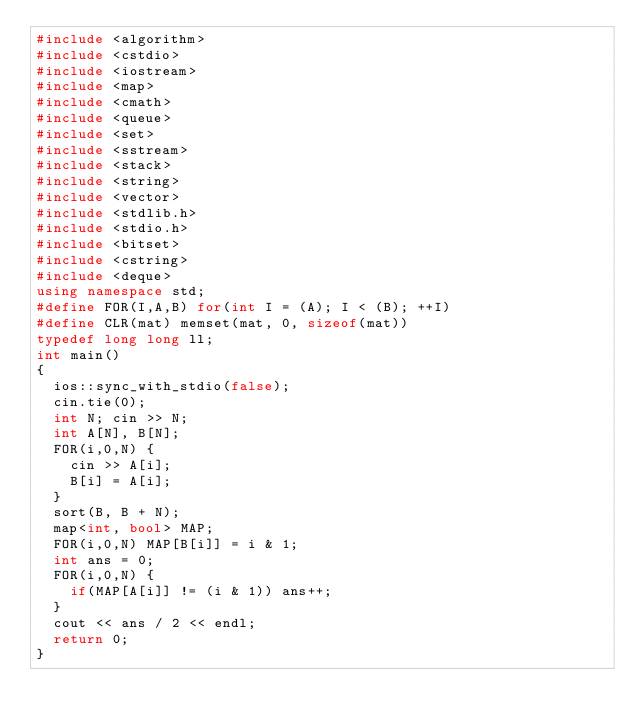<code> <loc_0><loc_0><loc_500><loc_500><_C++_>#include <algorithm>
#include <cstdio>
#include <iostream>
#include <map>
#include <cmath>
#include <queue>
#include <set>
#include <sstream>
#include <stack>
#include <string>
#include <vector>
#include <stdlib.h>
#include <stdio.h>
#include <bitset>
#include <cstring>
#include <deque>
using namespace std;
#define FOR(I,A,B) for(int I = (A); I < (B); ++I)
#define CLR(mat) memset(mat, 0, sizeof(mat))
typedef long long ll;
int main()
{
  ios::sync_with_stdio(false);
  cin.tie(0);
  int N; cin >> N;
  int A[N], B[N];
  FOR(i,0,N) {
    cin >> A[i];
    B[i] = A[i];
  }
  sort(B, B + N);
  map<int, bool> MAP;
  FOR(i,0,N) MAP[B[i]] = i & 1;
  int ans = 0;
  FOR(i,0,N) {
    if(MAP[A[i]] != (i & 1)) ans++;
  }
  cout << ans / 2 << endl;
  return 0;
}</code> 